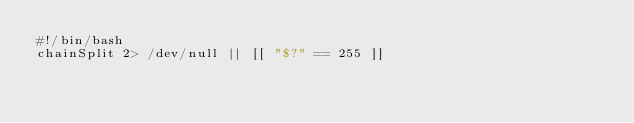<code> <loc_0><loc_0><loc_500><loc_500><_Bash_>#!/bin/bash
chainSplit 2> /dev/null || [[ "$?" == 255 ]]
</code> 